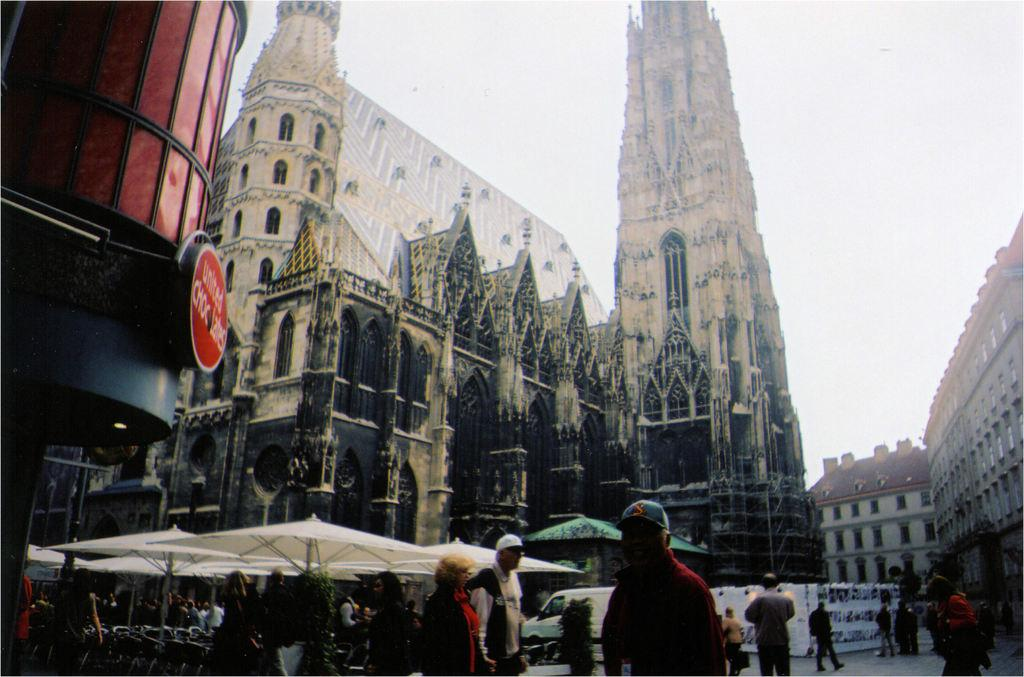What type of structures can be seen in the image? There are buildings in the image. What objects are being used by the people in the image? There are umbrellas in the image. Can you describe the group of people in the image? There is a group of people in the image. What can be seen in the background of the image? There is a van in the background of the image. What type of crime is being committed in the image? There is no indication of any crime being committed in the image. How are the people in the image maintaining their balance? The image does not provide any information about the people's balance. 